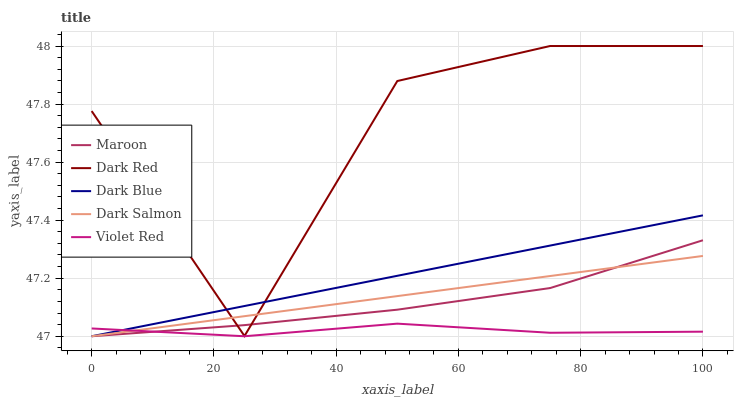Does Dark Salmon have the minimum area under the curve?
Answer yes or no. No. Does Dark Salmon have the maximum area under the curve?
Answer yes or no. No. Is Violet Red the smoothest?
Answer yes or no. No. Is Violet Red the roughest?
Answer yes or no. No. Does Dark Salmon have the highest value?
Answer yes or no. No. Is Violet Red less than Dark Red?
Answer yes or no. Yes. Is Dark Red greater than Violet Red?
Answer yes or no. Yes. Does Violet Red intersect Dark Red?
Answer yes or no. No. 